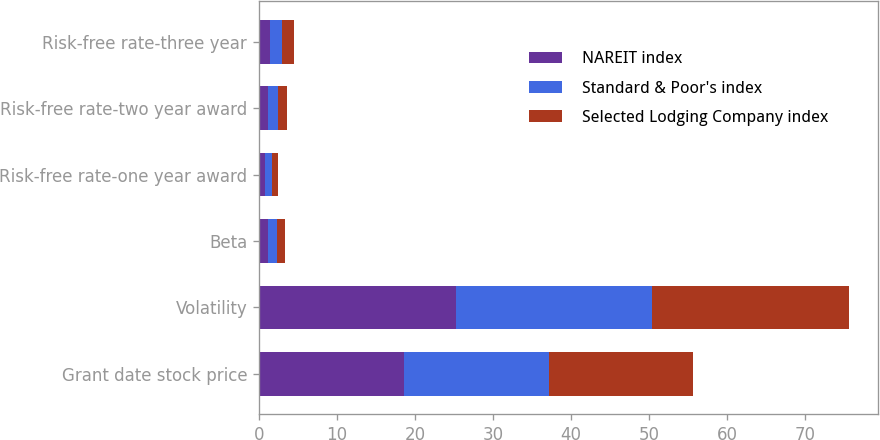<chart> <loc_0><loc_0><loc_500><loc_500><stacked_bar_chart><ecel><fcel>Grant date stock price<fcel>Volatility<fcel>Beta<fcel>Risk-free rate-one year award<fcel>Risk-free rate-two year award<fcel>Risk-free rate-three year<nl><fcel>NAREIT index<fcel>18.56<fcel>25.2<fcel>1.18<fcel>0.82<fcel>1.2<fcel>1.48<nl><fcel>Standard & Poor's index<fcel>18.56<fcel>25.2<fcel>1.18<fcel>0.82<fcel>1.2<fcel>1.48<nl><fcel>Selected Lodging Company index<fcel>18.56<fcel>25.2<fcel>1.01<fcel>0.82<fcel>1.2<fcel>1.48<nl></chart> 